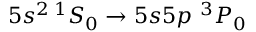<formula> <loc_0><loc_0><loc_500><loc_500>5 s ^ { 2 } \, ^ { 1 } S _ { 0 } \to 5 s 5 p \, ^ { 3 } P _ { 0 }</formula> 